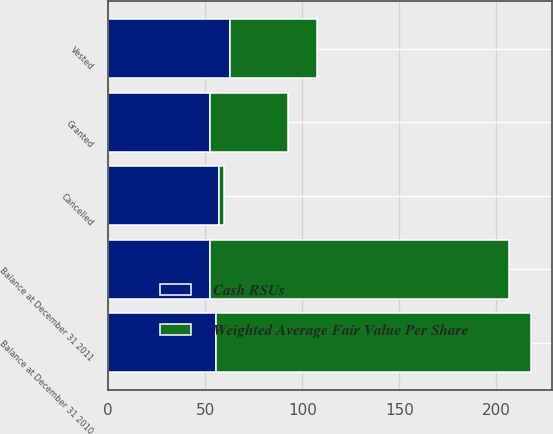Convert chart to OTSL. <chart><loc_0><loc_0><loc_500><loc_500><stacked_bar_chart><ecel><fcel>Balance at December 31 2010<fcel>Granted<fcel>Vested<fcel>Cancelled<fcel>Balance at December 31 2011<nl><fcel>Weighted Average Fair Value Per Share<fcel>162<fcel>40<fcel>45<fcel>3<fcel>154<nl><fcel>Cash RSUs<fcel>55.59<fcel>52.42<fcel>62.74<fcel>56.91<fcel>52.42<nl></chart> 